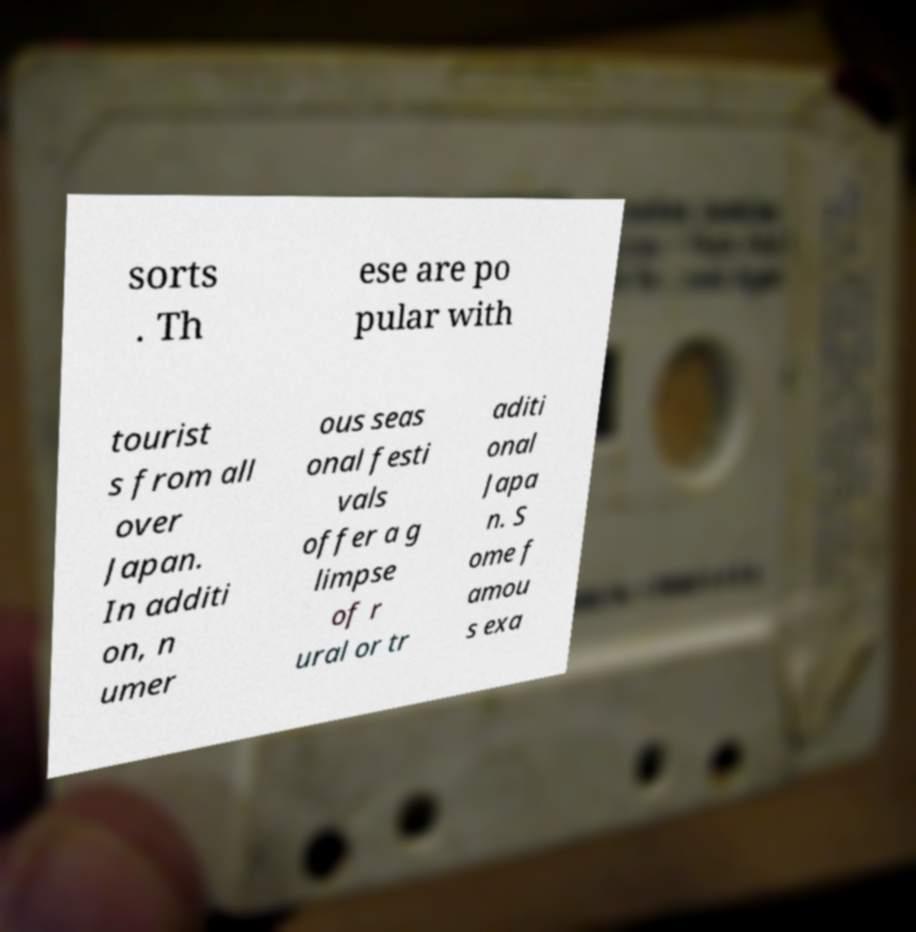Can you accurately transcribe the text from the provided image for me? sorts . Th ese are po pular with tourist s from all over Japan. In additi on, n umer ous seas onal festi vals offer a g limpse of r ural or tr aditi onal Japa n. S ome f amou s exa 